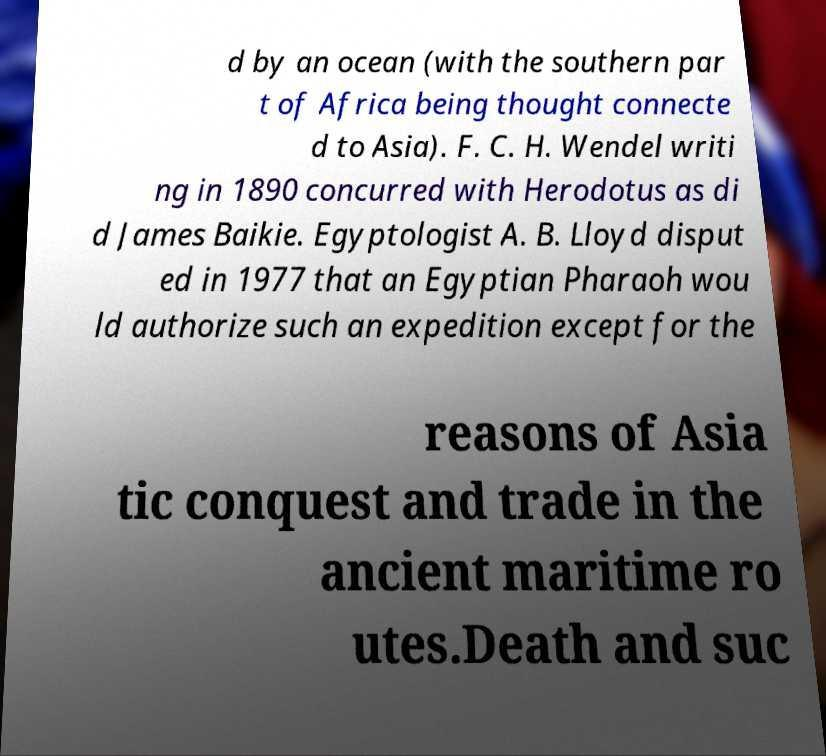Could you assist in decoding the text presented in this image and type it out clearly? d by an ocean (with the southern par t of Africa being thought connecte d to Asia). F. C. H. Wendel writi ng in 1890 concurred with Herodotus as di d James Baikie. Egyptologist A. B. Lloyd disput ed in 1977 that an Egyptian Pharaoh wou ld authorize such an expedition except for the reasons of Asia tic conquest and trade in the ancient maritime ro utes.Death and suc 